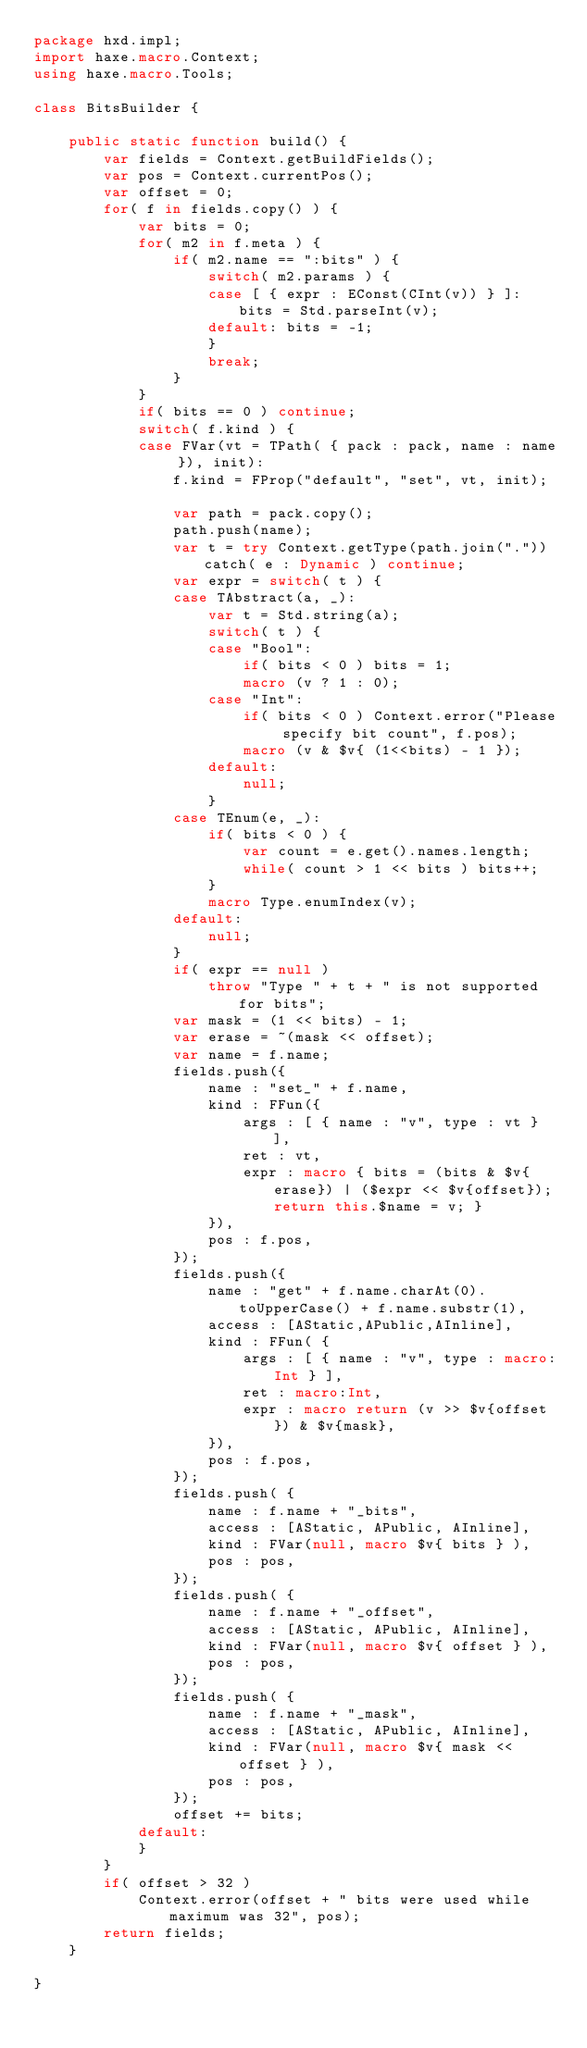Convert code to text. <code><loc_0><loc_0><loc_500><loc_500><_Haxe_>package hxd.impl;
import haxe.macro.Context;
using haxe.macro.Tools;

class BitsBuilder {

	public static function build() {
		var fields = Context.getBuildFields();
		var pos = Context.currentPos();
		var offset = 0;
		for( f in fields.copy() ) {
			var bits = 0;
			for( m2 in f.meta ) {
				if( m2.name == ":bits" ) {
					switch( m2.params ) {
					case [ { expr : EConst(CInt(v)) } ]: bits = Std.parseInt(v);
					default: bits = -1;
					}
					break;
				}
			}
			if( bits == 0 ) continue;
			switch( f.kind ) {
			case FVar(vt = TPath( { pack : pack, name : name }), init):
				f.kind = FProp("default", "set", vt, init);

				var path = pack.copy();
				path.push(name);
				var t = try Context.getType(path.join(".")) catch( e : Dynamic ) continue;
				var expr = switch( t ) {
				case TAbstract(a, _):
					var t = Std.string(a);
					switch( t ) {
					case "Bool":
						if( bits < 0 ) bits = 1;
						macro (v ? 1 : 0);
					case "Int":
						if( bits < 0 ) Context.error("Please specify bit count", f.pos);
						macro (v & $v{ (1<<bits) - 1 });
					default:
						null;
					}
				case TEnum(e, _):
					if( bits < 0 ) {
						var count = e.get().names.length;
						while( count > 1 << bits ) bits++;
					}
					macro Type.enumIndex(v);
				default:
					null;
				}
				if( expr == null )
					throw "Type " + t + " is not supported for bits";
				var mask = (1 << bits) - 1;
				var erase = ~(mask << offset);
				var name = f.name;
				fields.push({
					name : "set_" + f.name,
					kind : FFun({
						args : [ { name : "v", type : vt } ],
						ret : vt,
						expr : macro { bits = (bits & $v{erase}) | ($expr << $v{offset}); return this.$name = v; }
					}),
					pos : f.pos,
				});
				fields.push({
					name : "get" + f.name.charAt(0).toUpperCase() + f.name.substr(1),
					access : [AStatic,APublic,AInline],
					kind : FFun( {
						args : [ { name : "v", type : macro:Int } ],
						ret : macro:Int,
						expr : macro return (v >> $v{offset}) & $v{mask},
					}),
					pos : f.pos,
				});
				fields.push( {
					name : f.name + "_bits",
					access : [AStatic, APublic, AInline],
					kind : FVar(null, macro $v{ bits } ),
					pos : pos,
				});
				fields.push( {
					name : f.name + "_offset",
					access : [AStatic, APublic, AInline],
					kind : FVar(null, macro $v{ offset } ),
					pos : pos,
				});
				fields.push( {
					name : f.name + "_mask",
					access : [AStatic, APublic, AInline],
					kind : FVar(null, macro $v{ mask << offset } ),
					pos : pos,
				});
				offset += bits;
			default:
			}
		}
		if( offset > 32 )
			Context.error(offset + " bits were used while maximum was 32", pos);
		return fields;
	}

}</code> 